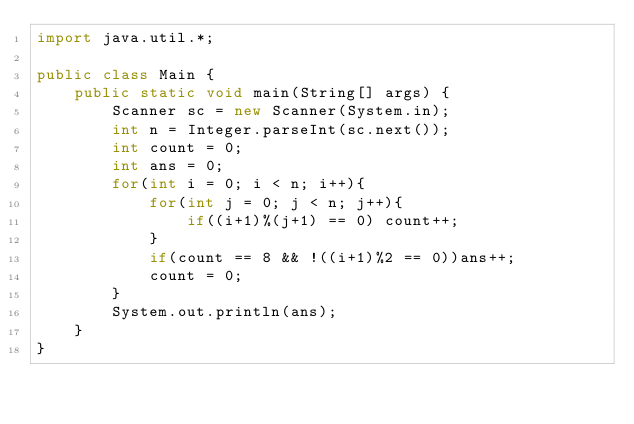<code> <loc_0><loc_0><loc_500><loc_500><_Java_>import java.util.*;

public class Main {
    public static void main(String[] args) {
        Scanner sc = new Scanner(System.in);
        int n = Integer.parseInt(sc.next());
        int count = 0;
        int ans = 0;
        for(int i = 0; i < n; i++){
            for(int j = 0; j < n; j++){
                if((i+1)%(j+1) == 0) count++;
            }
            if(count == 8 && !((i+1)%2 == 0))ans++;
            count = 0;
        }
        System.out.println(ans);
    }
}</code> 